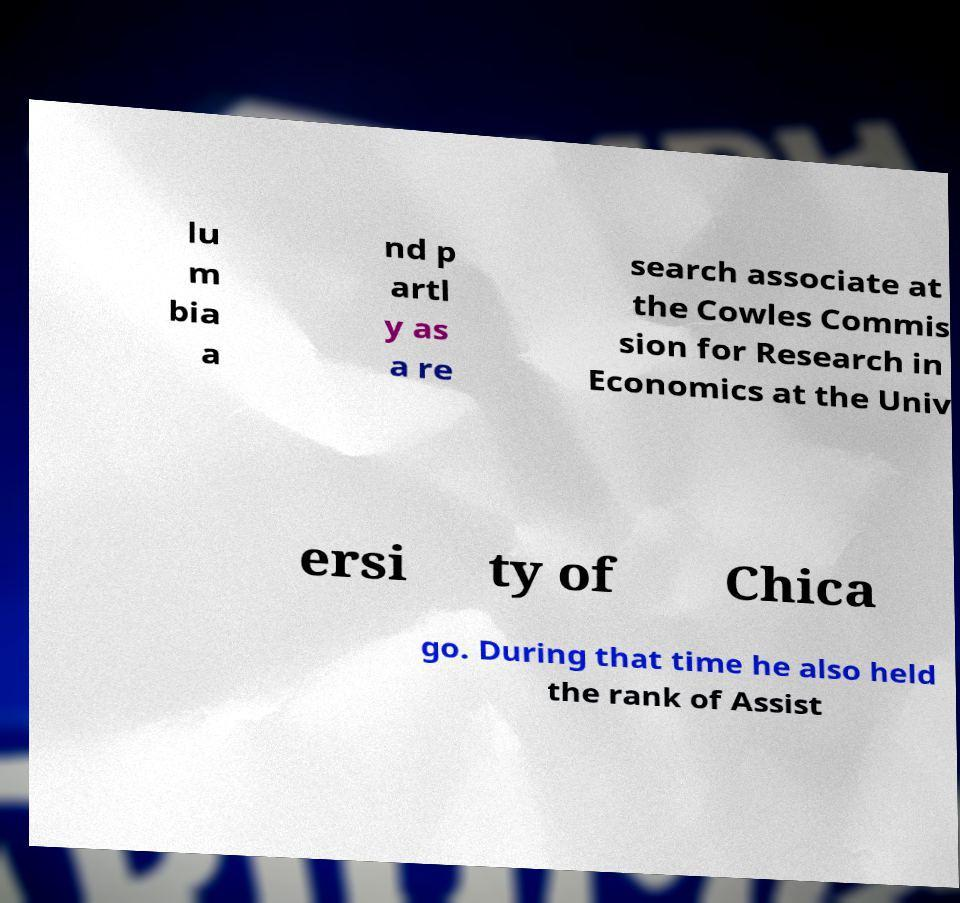Can you accurately transcribe the text from the provided image for me? lu m bia a nd p artl y as a re search associate at the Cowles Commis sion for Research in Economics at the Univ ersi ty of Chica go. During that time he also held the rank of Assist 